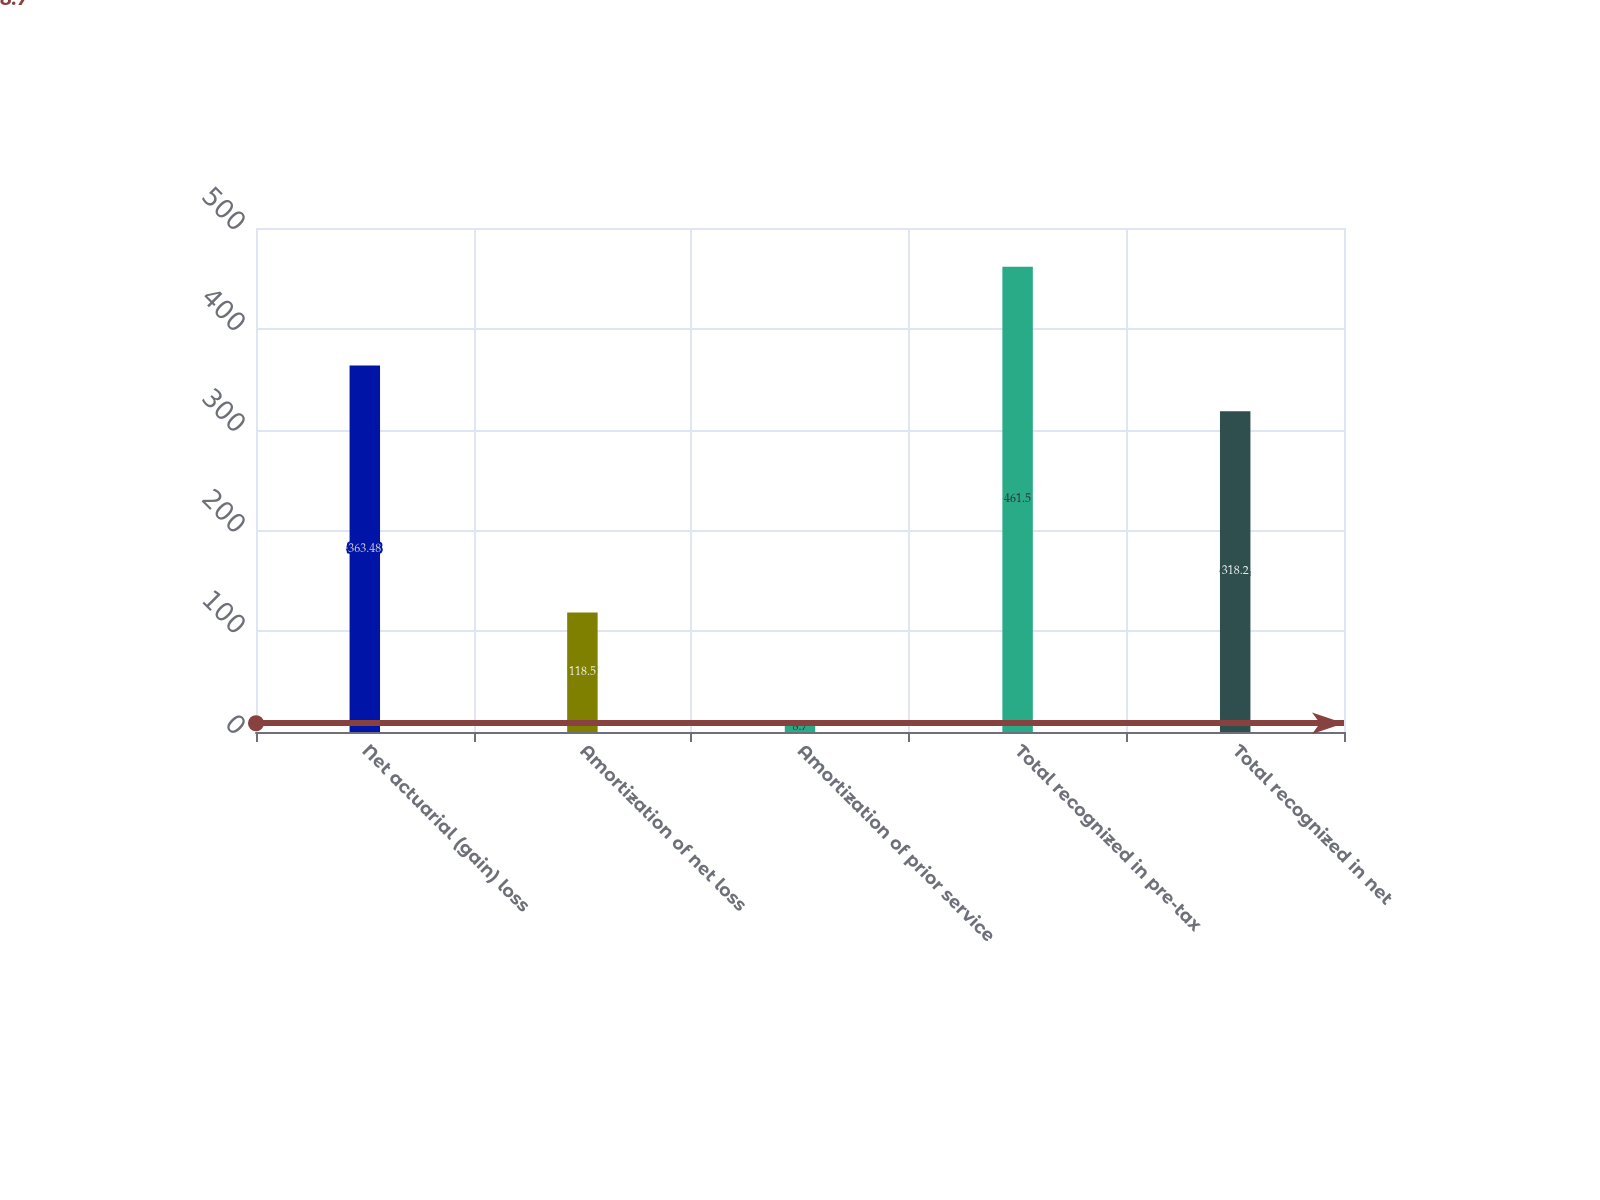<chart> <loc_0><loc_0><loc_500><loc_500><bar_chart><fcel>Net actuarial (gain) loss<fcel>Amortization of net loss<fcel>Amortization of prior service<fcel>Total recognized in pre-tax<fcel>Total recognized in net<nl><fcel>363.48<fcel>118.5<fcel>8.7<fcel>461.5<fcel>318.2<nl></chart> 